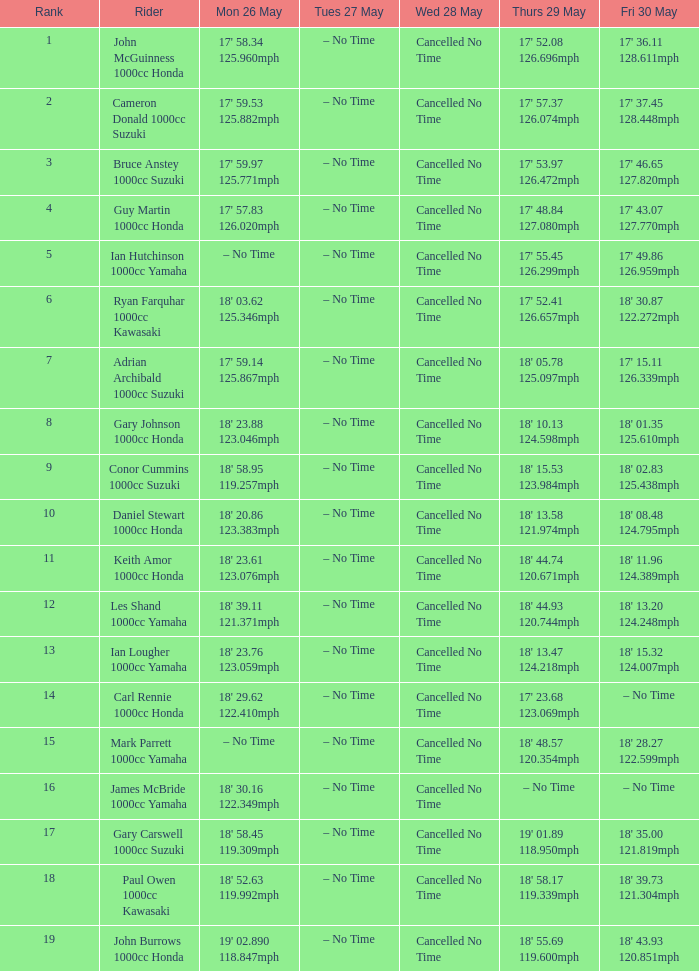34 and 12 Cancelled No Time. 